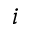Convert formula to latex. <formula><loc_0><loc_0><loc_500><loc_500>i</formula> 